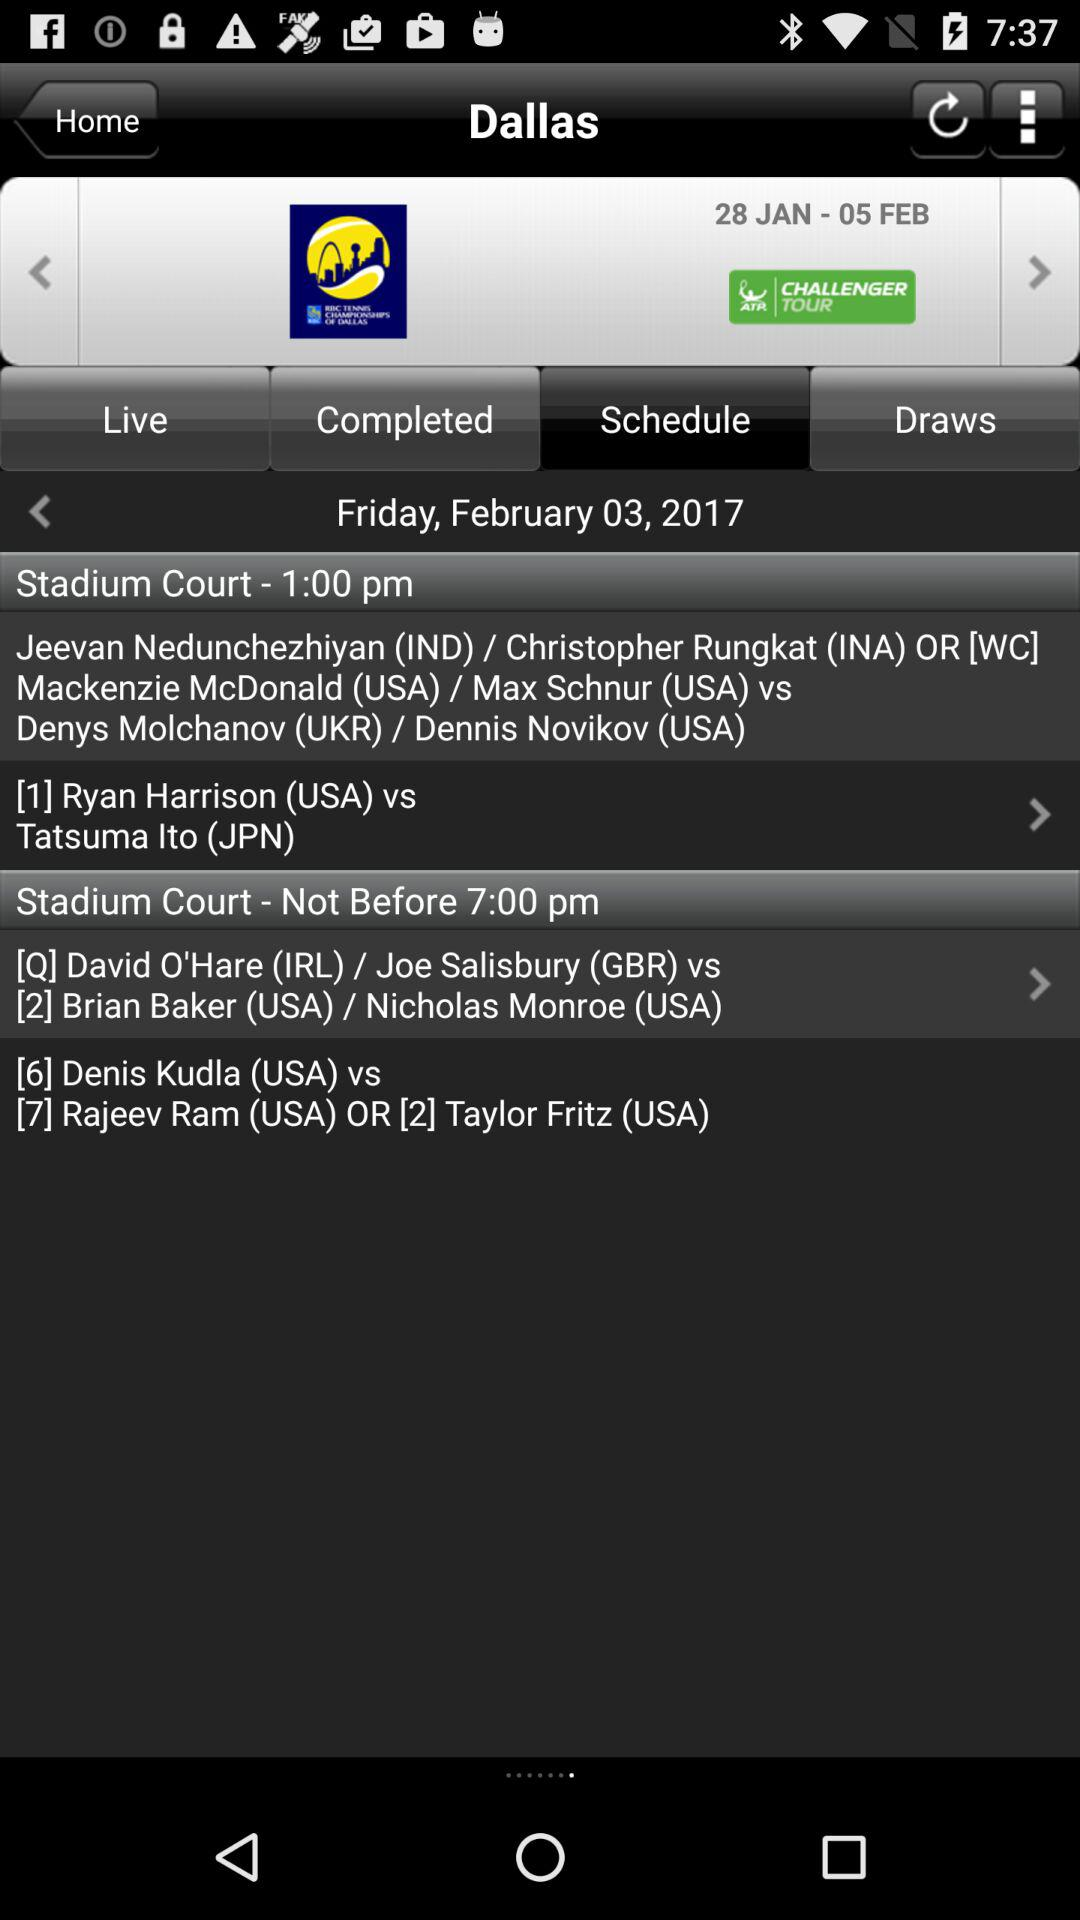Which option is selected? The selected option is "Schedule". 